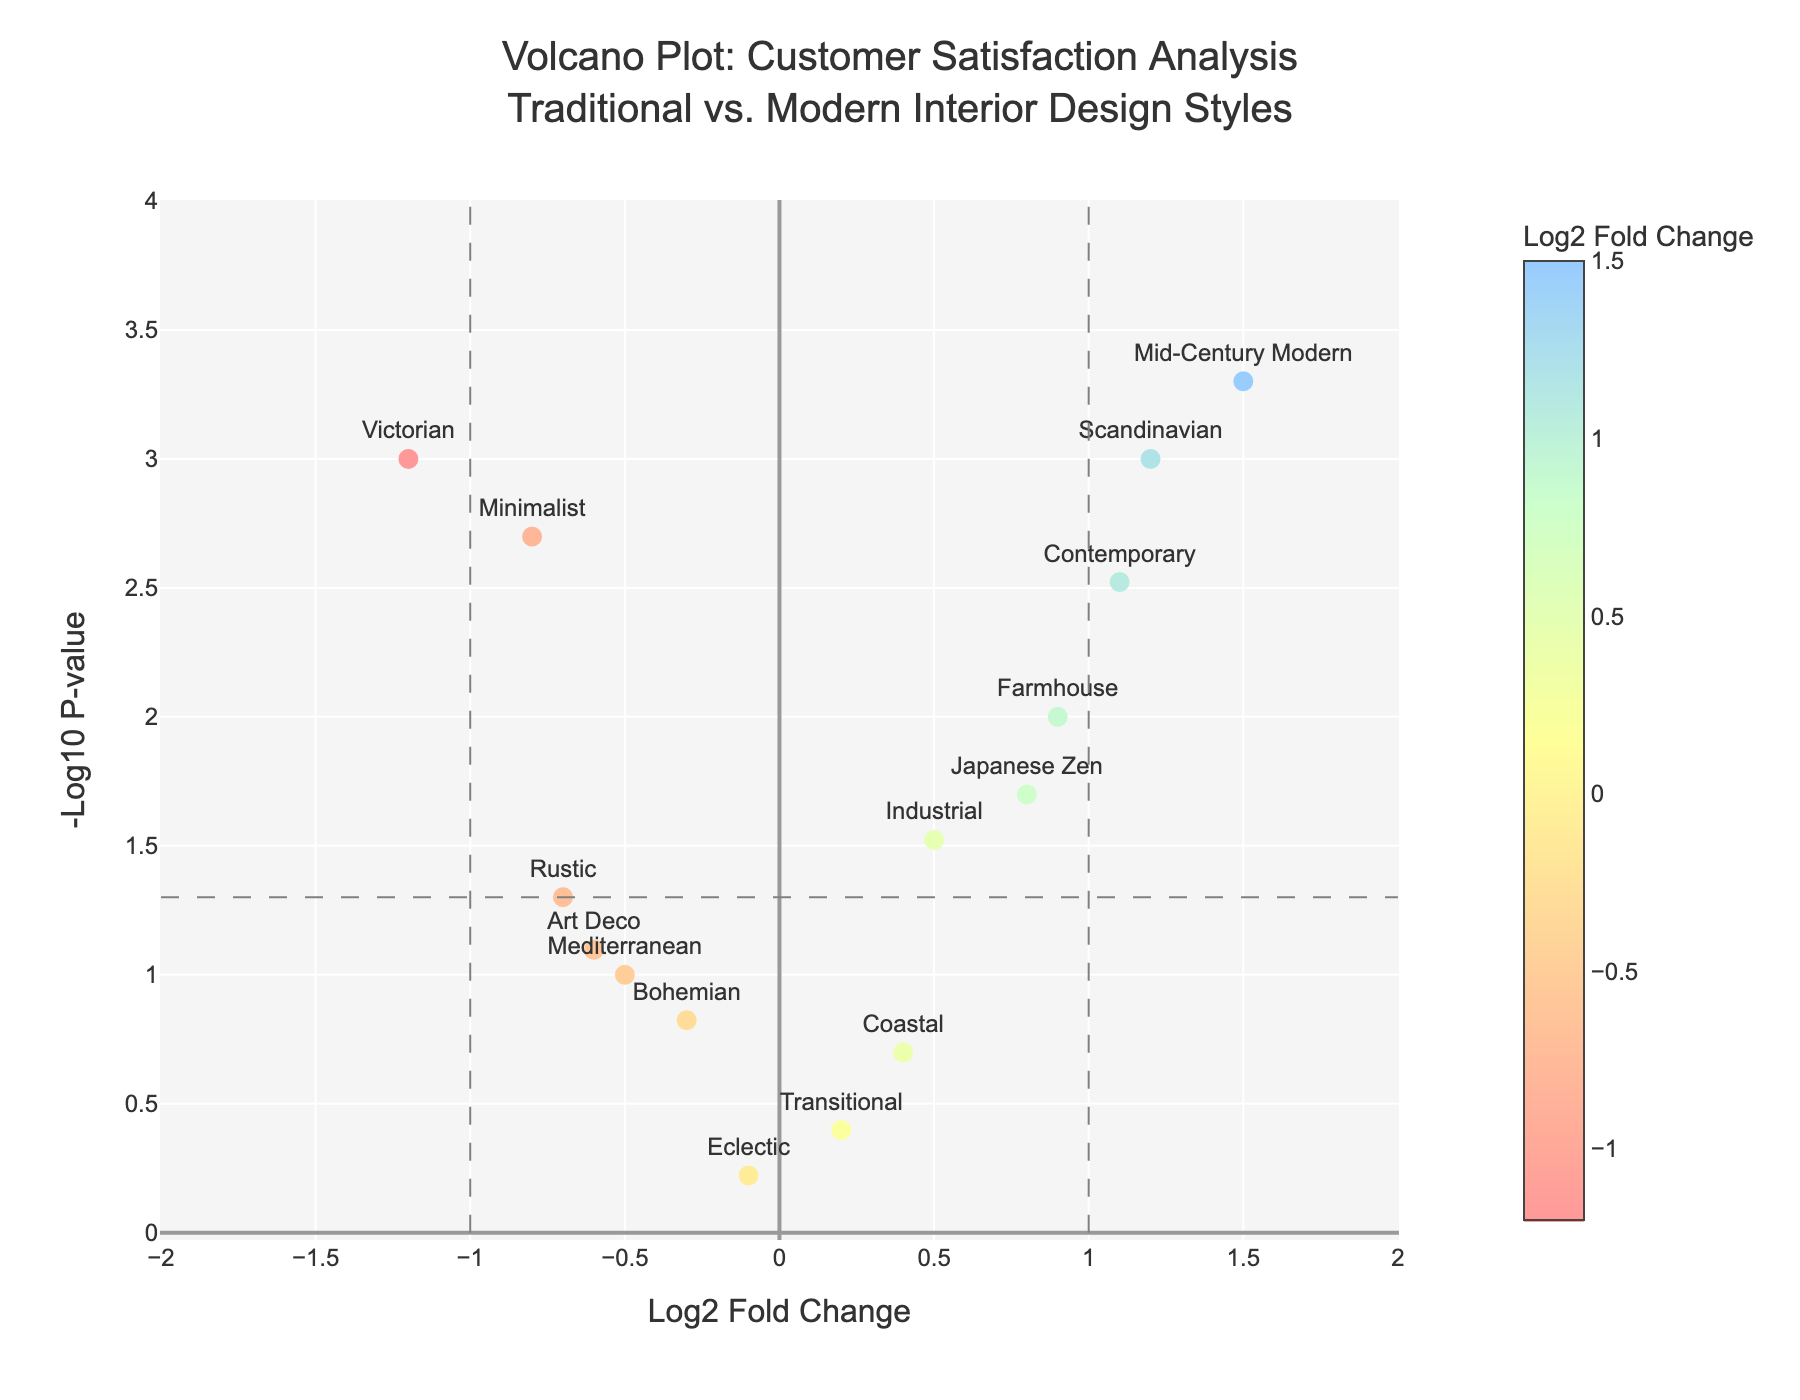What is the title of the volcano plot? The title is located at the top of the figure and reads, "Volcano Plot: Customer Satisfaction Analysis<br>Traditional vs. Modern Interior Design Styles". This indicates the plot compares customer satisfaction between traditional and modern interior design styles.
Answer: Volcano Plot: Customer Satisfaction Analysis<br>Traditional vs. Modern Interior Design Styles How many interior design styles are represented in the plot? Each point on the plot represents an interior design style. By counting each data point, we can determine the number of styles. From the provided data, there are 14 points.
Answer: 14 What does the y-axis represent in the volcano plot? The y-axis is labeled as "-Log10 P-value". This means it shows the negative logarithm (base 10) of the p-values of the respective interior design styles.
Answer: -Log10 P-value Which interior design style has the highest customer satisfaction as indicated by the log2 fold change? The highest log2 fold change represents the style with the largest positive customer satisfaction change. By looking at the x-axis, "Mid-Century Modern" has the highest log2 fold change of 1.5.
Answer: Mid-Century Modern What is the log2 fold change and p-value of the Victorian style? The data points include Victorian, whose log2 fold change is -1.2 and p-value is 0.001. These positions correspond to the x and y coordinates of the point labeled "Victorian" on the plot.
Answer: Log2 fold change: -1.2, P-value: 0.001 Which styles have statistically significant changes in customer satisfaction? Statistically significant changes are indicated by data points above the horizontal line at -log10(0.05), which is the threshold for significance. The styles above this line include Minimalist, Scandinavian, Mid-Century Modern, Farmhouse, Contemporary, Japanese Zen, and Victorian.
Answer: Minimalist, Scandinavian, Mid-Century Modern, Farmhouse, Contemporary, Japanese Zen, Victorian What is the p-value threshold that indicates statistical significance in this plot? A horizontal dashed line represents the -log10 transformed p-value threshold, which is calculated as -log10(0.05). This corresponds to a p-value threshold of 0.05 for statistical significance.
Answer: 0.05 Compare the customer satisfaction changes between "Industrial" and "Rustic". Which style shows a greater increase or decrease? The "Industrial" style has a log2 fold change of 0.5, while "Rustic" has a log2 fold change of -0.7. A positive log2 fold change indicates an increase in satisfaction, and a negative indicates a decrease. Therefore, "Industrial" shows an increase and "Rustic" shows a decrease.
Answer: Industrial: increase, Rustic: decrease What can you infer from the positions of "Scandinavian" and "Victorian" on the volcano plot in terms of customer preferences? "Scandinavian" is positioned with a high positive log2 fold change (1.2) and low p-value (0.001), suggesting it is highly preferred. "Victorian" has a high negative log2 fold change (-1.2) and similar low p-value (0.001), indicating it is less preferred. This infers that customers significantly prefer "Scandinavian" over "Victorian".
Answer: Scandinavian preferred, Victorian less preferred Which interior design style has a log2 fold change closest to zero and what does this indicate about customer satisfaction? "Transitional" has a log2 fold change of 0.2, which is closest to zero. A log2 fold change near zero suggests there is little to no change in customer satisfaction for this style.
Answer: Transitional 